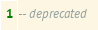<code> <loc_0><loc_0><loc_500><loc_500><_SQL_>-- deprecated
</code> 